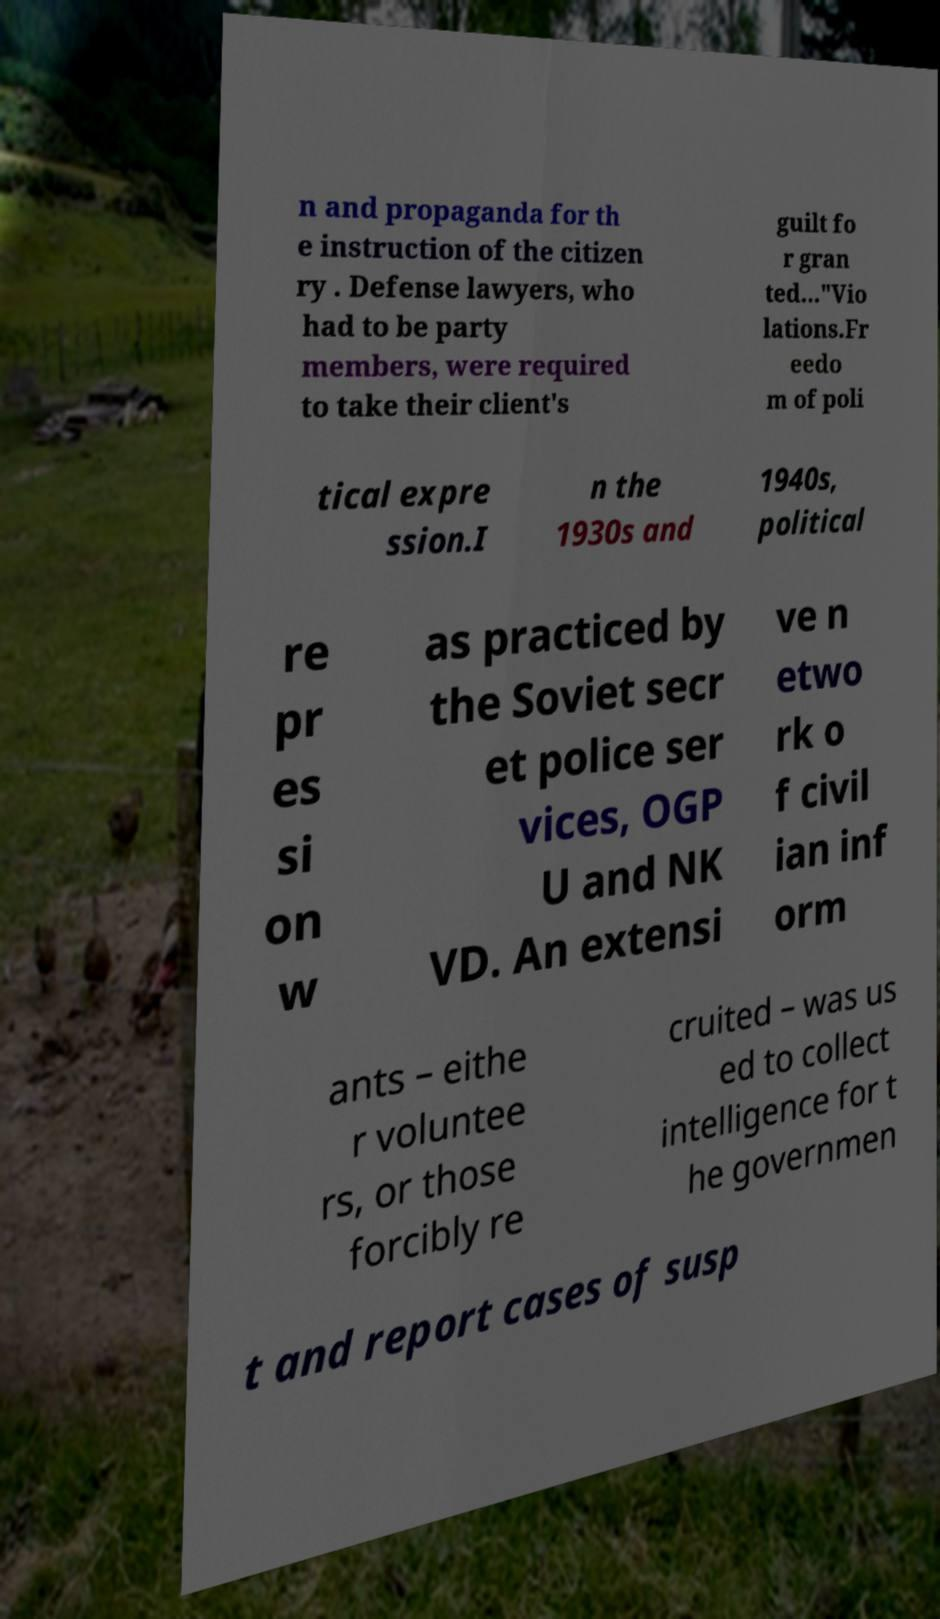Please identify and transcribe the text found in this image. n and propaganda for th e instruction of the citizen ry . Defense lawyers, who had to be party members, were required to take their client's guilt fo r gran ted..."Vio lations.Fr eedo m of poli tical expre ssion.I n the 1930s and 1940s, political re pr es si on w as practiced by the Soviet secr et police ser vices, OGP U and NK VD. An extensi ve n etwo rk o f civil ian inf orm ants – eithe r voluntee rs, or those forcibly re cruited – was us ed to collect intelligence for t he governmen t and report cases of susp 